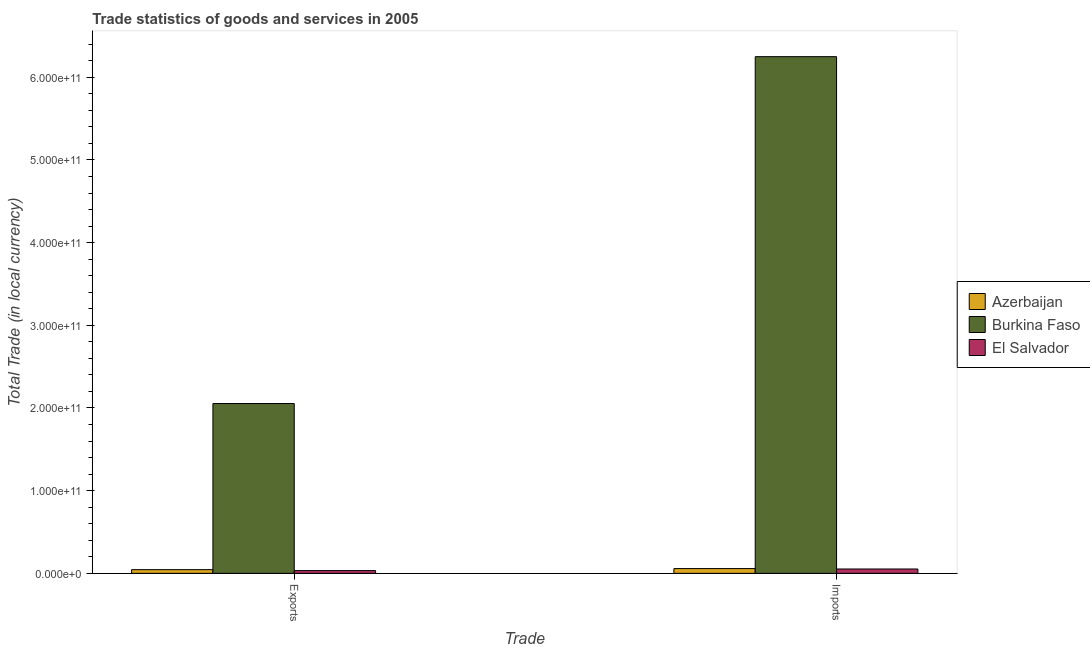How many different coloured bars are there?
Give a very brief answer. 3. How many groups of bars are there?
Your answer should be very brief. 2. Are the number of bars on each tick of the X-axis equal?
Ensure brevity in your answer.  Yes. How many bars are there on the 2nd tick from the right?
Your answer should be compact. 3. What is the label of the 1st group of bars from the left?
Provide a short and direct response. Exports. What is the export of goods and services in Burkina Faso?
Your response must be concise. 2.05e+11. Across all countries, what is the maximum export of goods and services?
Your answer should be compact. 2.05e+11. Across all countries, what is the minimum export of goods and services?
Your answer should be compact. 3.30e+09. In which country was the export of goods and services maximum?
Provide a succinct answer. Burkina Faso. In which country was the imports of goods and services minimum?
Your answer should be compact. El Salvador. What is the total export of goods and services in the graph?
Make the answer very short. 2.13e+11. What is the difference between the export of goods and services in Azerbaijan and that in El Salvador?
Provide a short and direct response. 1.16e+09. What is the difference between the export of goods and services in El Salvador and the imports of goods and services in Azerbaijan?
Provide a short and direct response. -2.44e+09. What is the average imports of goods and services per country?
Ensure brevity in your answer.  2.12e+11. What is the difference between the export of goods and services and imports of goods and services in Burkina Faso?
Ensure brevity in your answer.  -4.20e+11. What is the ratio of the imports of goods and services in Azerbaijan to that in El Salvador?
Offer a terse response. 1.09. What does the 1st bar from the left in Imports represents?
Your response must be concise. Azerbaijan. What does the 3rd bar from the right in Exports represents?
Provide a short and direct response. Azerbaijan. How many bars are there?
Provide a short and direct response. 6. What is the difference between two consecutive major ticks on the Y-axis?
Give a very brief answer. 1.00e+11. Are the values on the major ticks of Y-axis written in scientific E-notation?
Ensure brevity in your answer.  Yes. Does the graph contain any zero values?
Offer a terse response. No. Does the graph contain grids?
Offer a very short reply. No. How many legend labels are there?
Ensure brevity in your answer.  3. How are the legend labels stacked?
Provide a short and direct response. Vertical. What is the title of the graph?
Your answer should be very brief. Trade statistics of goods and services in 2005. Does "Malta" appear as one of the legend labels in the graph?
Your answer should be compact. No. What is the label or title of the X-axis?
Give a very brief answer. Trade. What is the label or title of the Y-axis?
Give a very brief answer. Total Trade (in local currency). What is the Total Trade (in local currency) in Azerbaijan in Exports?
Give a very brief answer. 4.46e+09. What is the Total Trade (in local currency) in Burkina Faso in Exports?
Offer a terse response. 2.05e+11. What is the Total Trade (in local currency) of El Salvador in Exports?
Give a very brief answer. 3.30e+09. What is the Total Trade (in local currency) of Azerbaijan in Imports?
Provide a short and direct response. 5.74e+09. What is the Total Trade (in local currency) of Burkina Faso in Imports?
Offer a very short reply. 6.25e+11. What is the Total Trade (in local currency) of El Salvador in Imports?
Keep it short and to the point. 5.24e+09. Across all Trade, what is the maximum Total Trade (in local currency) of Azerbaijan?
Ensure brevity in your answer.  5.74e+09. Across all Trade, what is the maximum Total Trade (in local currency) of Burkina Faso?
Provide a short and direct response. 6.25e+11. Across all Trade, what is the maximum Total Trade (in local currency) of El Salvador?
Make the answer very short. 5.24e+09. Across all Trade, what is the minimum Total Trade (in local currency) of Azerbaijan?
Offer a very short reply. 4.46e+09. Across all Trade, what is the minimum Total Trade (in local currency) in Burkina Faso?
Make the answer very short. 2.05e+11. Across all Trade, what is the minimum Total Trade (in local currency) in El Salvador?
Your response must be concise. 3.30e+09. What is the total Total Trade (in local currency) of Azerbaijan in the graph?
Offer a very short reply. 1.02e+1. What is the total Total Trade (in local currency) in Burkina Faso in the graph?
Your response must be concise. 8.30e+11. What is the total Total Trade (in local currency) in El Salvador in the graph?
Offer a very short reply. 8.55e+09. What is the difference between the Total Trade (in local currency) in Azerbaijan in Exports and that in Imports?
Provide a succinct answer. -1.28e+09. What is the difference between the Total Trade (in local currency) of Burkina Faso in Exports and that in Imports?
Offer a terse response. -4.20e+11. What is the difference between the Total Trade (in local currency) in El Salvador in Exports and that in Imports?
Your answer should be very brief. -1.94e+09. What is the difference between the Total Trade (in local currency) of Azerbaijan in Exports and the Total Trade (in local currency) of Burkina Faso in Imports?
Your response must be concise. -6.20e+11. What is the difference between the Total Trade (in local currency) of Azerbaijan in Exports and the Total Trade (in local currency) of El Salvador in Imports?
Your answer should be very brief. -7.81e+08. What is the difference between the Total Trade (in local currency) in Burkina Faso in Exports and the Total Trade (in local currency) in El Salvador in Imports?
Offer a terse response. 2.00e+11. What is the average Total Trade (in local currency) of Azerbaijan per Trade?
Offer a terse response. 5.10e+09. What is the average Total Trade (in local currency) of Burkina Faso per Trade?
Ensure brevity in your answer.  4.15e+11. What is the average Total Trade (in local currency) of El Salvador per Trade?
Provide a succinct answer. 4.27e+09. What is the difference between the Total Trade (in local currency) in Azerbaijan and Total Trade (in local currency) in Burkina Faso in Exports?
Ensure brevity in your answer.  -2.01e+11. What is the difference between the Total Trade (in local currency) in Azerbaijan and Total Trade (in local currency) in El Salvador in Exports?
Ensure brevity in your answer.  1.16e+09. What is the difference between the Total Trade (in local currency) of Burkina Faso and Total Trade (in local currency) of El Salvador in Exports?
Give a very brief answer. 2.02e+11. What is the difference between the Total Trade (in local currency) of Azerbaijan and Total Trade (in local currency) of Burkina Faso in Imports?
Give a very brief answer. -6.19e+11. What is the difference between the Total Trade (in local currency) of Azerbaijan and Total Trade (in local currency) of El Salvador in Imports?
Your response must be concise. 4.98e+08. What is the difference between the Total Trade (in local currency) of Burkina Faso and Total Trade (in local currency) of El Salvador in Imports?
Your response must be concise. 6.20e+11. What is the ratio of the Total Trade (in local currency) of Azerbaijan in Exports to that in Imports?
Ensure brevity in your answer.  0.78. What is the ratio of the Total Trade (in local currency) in Burkina Faso in Exports to that in Imports?
Offer a very short reply. 0.33. What is the ratio of the Total Trade (in local currency) of El Salvador in Exports to that in Imports?
Your answer should be very brief. 0.63. What is the difference between the highest and the second highest Total Trade (in local currency) in Azerbaijan?
Provide a short and direct response. 1.28e+09. What is the difference between the highest and the second highest Total Trade (in local currency) in Burkina Faso?
Your answer should be very brief. 4.20e+11. What is the difference between the highest and the second highest Total Trade (in local currency) in El Salvador?
Ensure brevity in your answer.  1.94e+09. What is the difference between the highest and the lowest Total Trade (in local currency) of Azerbaijan?
Your answer should be very brief. 1.28e+09. What is the difference between the highest and the lowest Total Trade (in local currency) of Burkina Faso?
Ensure brevity in your answer.  4.20e+11. What is the difference between the highest and the lowest Total Trade (in local currency) in El Salvador?
Give a very brief answer. 1.94e+09. 